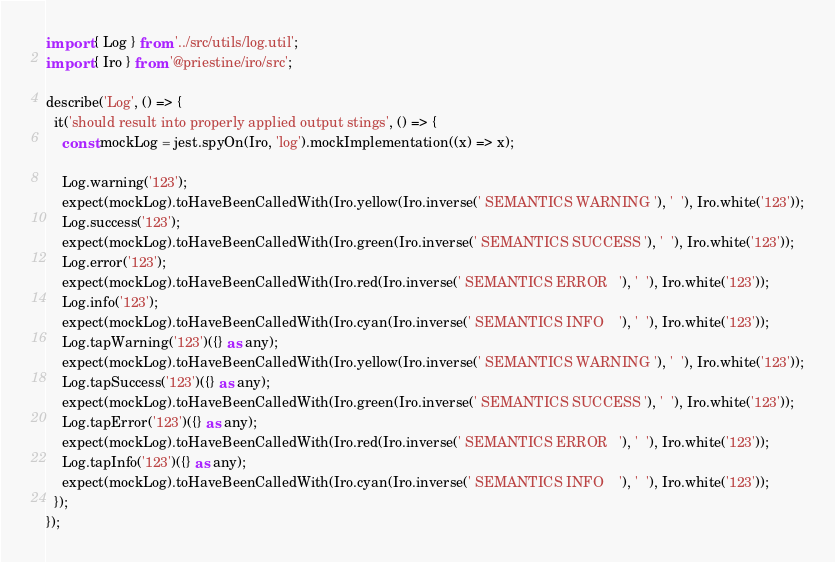<code> <loc_0><loc_0><loc_500><loc_500><_TypeScript_>import { Log } from '../src/utils/log.util';
import { Iro } from '@priestine/iro/src';

describe('Log', () => {
  it('should result into properly applied output stings', () => {
    const mockLog = jest.spyOn(Iro, 'log').mockImplementation((x) => x);

    Log.warning('123');
    expect(mockLog).toHaveBeenCalledWith(Iro.yellow(Iro.inverse(' SEMANTICS WARNING '), '  '), Iro.white('123'));
    Log.success('123');
    expect(mockLog).toHaveBeenCalledWith(Iro.green(Iro.inverse(' SEMANTICS SUCCESS '), '  '), Iro.white('123'));
    Log.error('123');
    expect(mockLog).toHaveBeenCalledWith(Iro.red(Iro.inverse(' SEMANTICS ERROR   '), '  '), Iro.white('123'));
    Log.info('123');
    expect(mockLog).toHaveBeenCalledWith(Iro.cyan(Iro.inverse(' SEMANTICS INFO    '), '  '), Iro.white('123'));
    Log.tapWarning('123')({} as any);
    expect(mockLog).toHaveBeenCalledWith(Iro.yellow(Iro.inverse(' SEMANTICS WARNING '), '  '), Iro.white('123'));
    Log.tapSuccess('123')({} as any);
    expect(mockLog).toHaveBeenCalledWith(Iro.green(Iro.inverse(' SEMANTICS SUCCESS '), '  '), Iro.white('123'));
    Log.tapError('123')({} as any);
    expect(mockLog).toHaveBeenCalledWith(Iro.red(Iro.inverse(' SEMANTICS ERROR   '), '  '), Iro.white('123'));
    Log.tapInfo('123')({} as any);
    expect(mockLog).toHaveBeenCalledWith(Iro.cyan(Iro.inverse(' SEMANTICS INFO    '), '  '), Iro.white('123'));
  });
});
</code> 